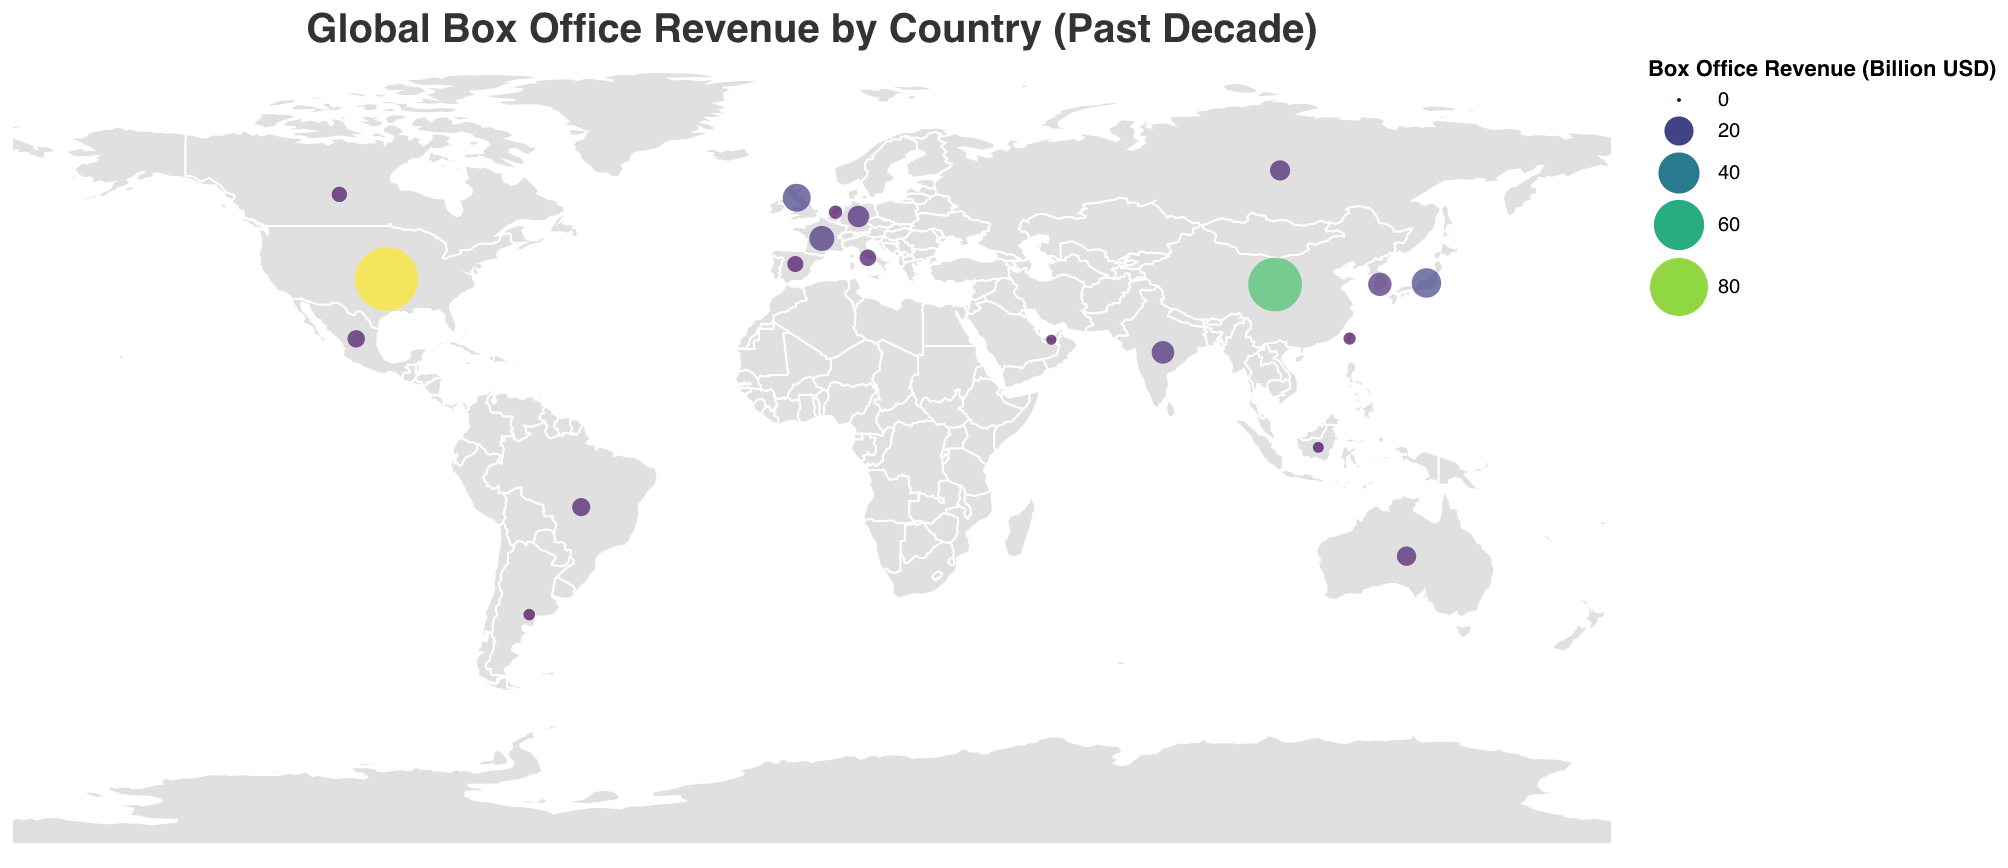How much is the box office revenue for the United States? The figure indicates the box office revenue for the United States as clearly marked, which is 95.2 billion USD.
Answer: 95.2 billion USD Which country has the second highest box office revenue? By observing the figure, China is the country with the second highest box office revenue, indicated by its corresponding large circle size and color.
Answer: China What is the combined box office revenue of Japan and the United Kingdom? Japan's box office revenue is 20.5 billion USD, and the United Kingdom's is 18.3 billion USD. Adding these together: 20.5 + 18.3 = 38.8 billion USD.
Answer: 38.8 billion USD Which country has a higher box office revenue: France or South Korea? The figure shows that France's box office revenue is 14.6 billion USD, and South Korea's is 12.8 billion USD. Since 14.6 is greater than 12.8, France has a higher box office revenue.
Answer: France What is the total box office revenue of the countries listed in the figure? Summing up the box office revenues of all listed countries: 95.2 + 68.7 + 20.5 + 18.3 + 14.6 + 12.8 + 11.9 + 10.7 + 9.4 + 8.6 + 7.5 + 6.9 + 6.2 + 5.8 + 5.3 + 3.9 + 3.2 + 2.8 + 2.5 + 2.1 = 327.8 billion USD.
Answer: 327.8 billion USD What is the average box office revenue of all countries listed in the figure? The total box office revenue for all countries is 327.8 billion USD, and there are 20 countries listed. The average is calculated by dividing the total by the number of countries: 327.8 / 20 = 16.39 billion USD.
Answer: 16.39 billion USD Which country in South America has the highest box office revenue? Among the South American countries listed, Brazil has a box office revenue of 7.5 billion USD, and Argentina has 2.8 billion USD. Therefore, Brazil has the highest revenue in South America.
Answer: Brazil 